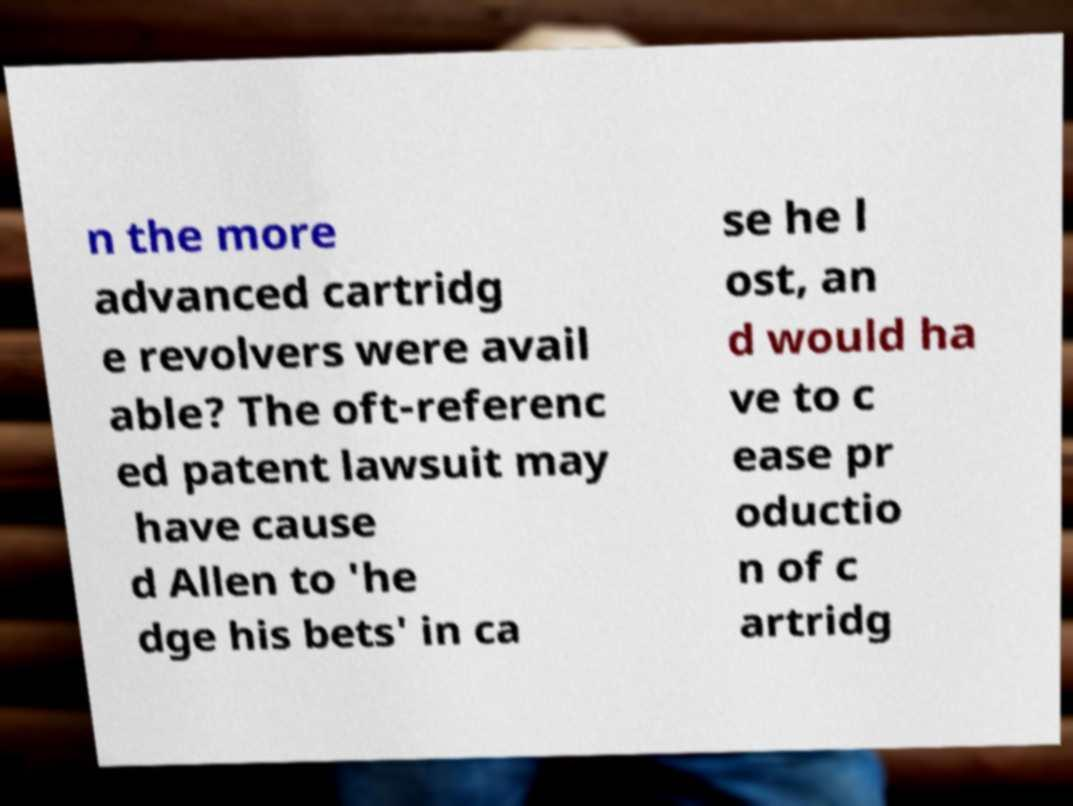There's text embedded in this image that I need extracted. Can you transcribe it verbatim? n the more advanced cartridg e revolvers were avail able? The oft-referenc ed patent lawsuit may have cause d Allen to 'he dge his bets' in ca se he l ost, an d would ha ve to c ease pr oductio n of c artridg 